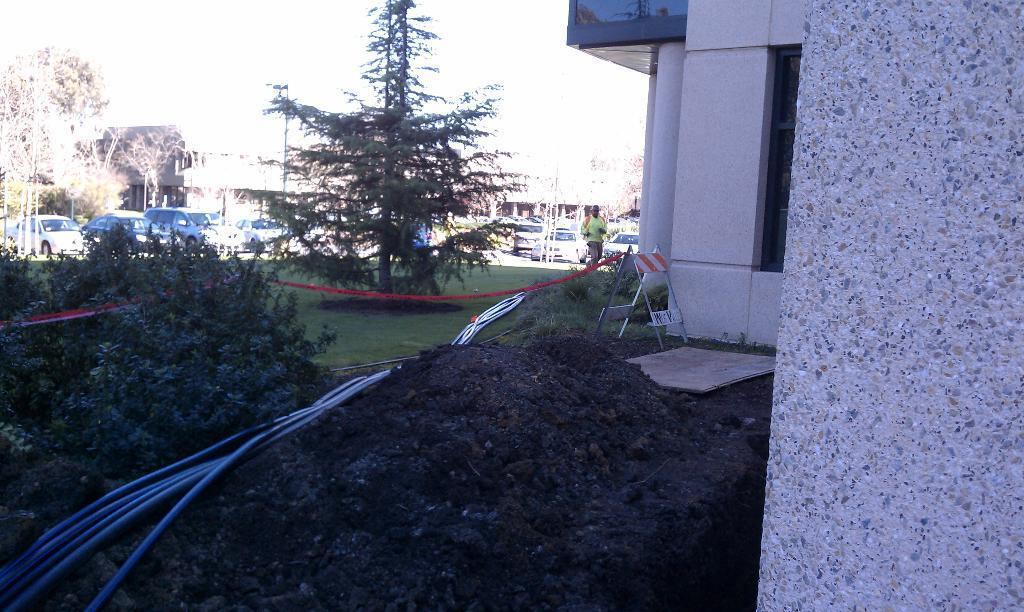Please provide a concise description of this image. In this image at the bottom there is mud, pipes, grass and some plants. And in the background there is one person, ladder, tape, vehicles, trees, buildings. On the left side of the image there is a building, and some board. At the top there is sky. 